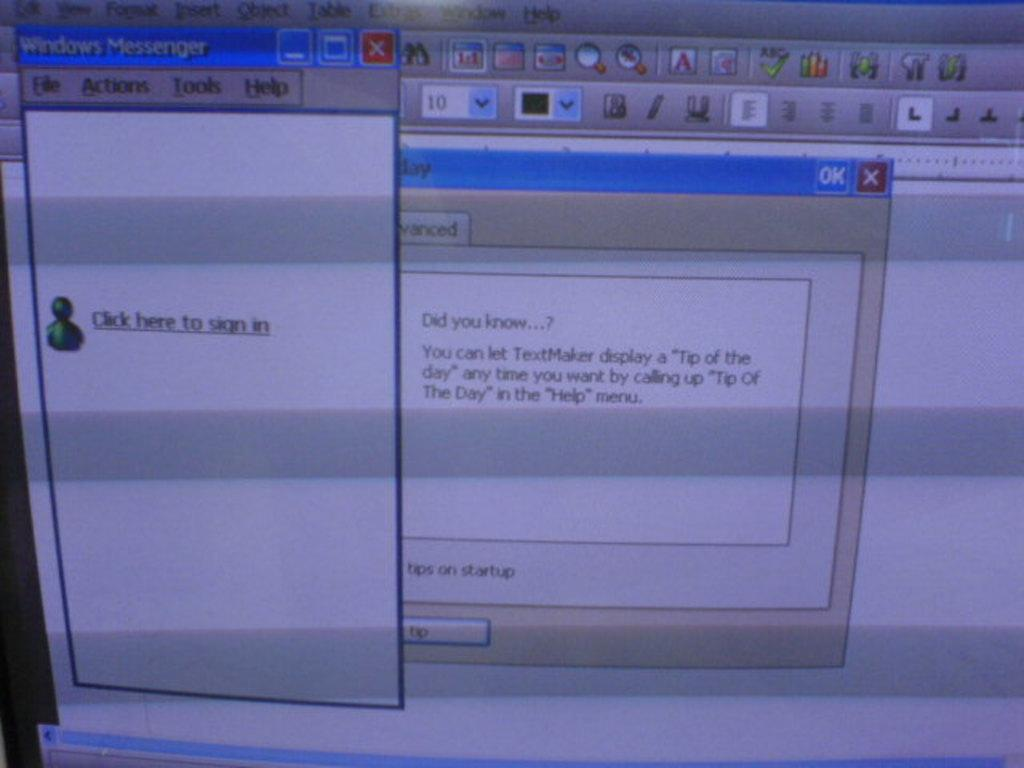<image>
Summarize the visual content of the image. Windows Messengers appears on the screen shot and prompts the user to sign in. 